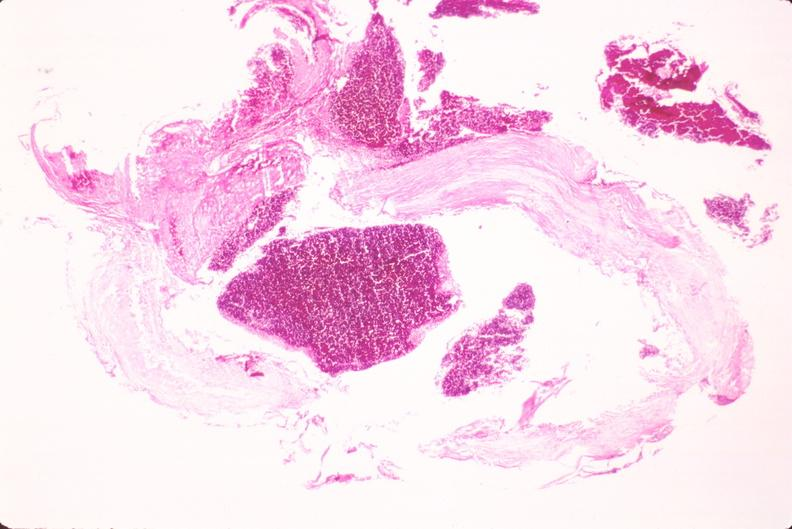does this image show ruptured saccular aneurysm right middle cerebral artery?
Answer the question using a single word or phrase. Yes 